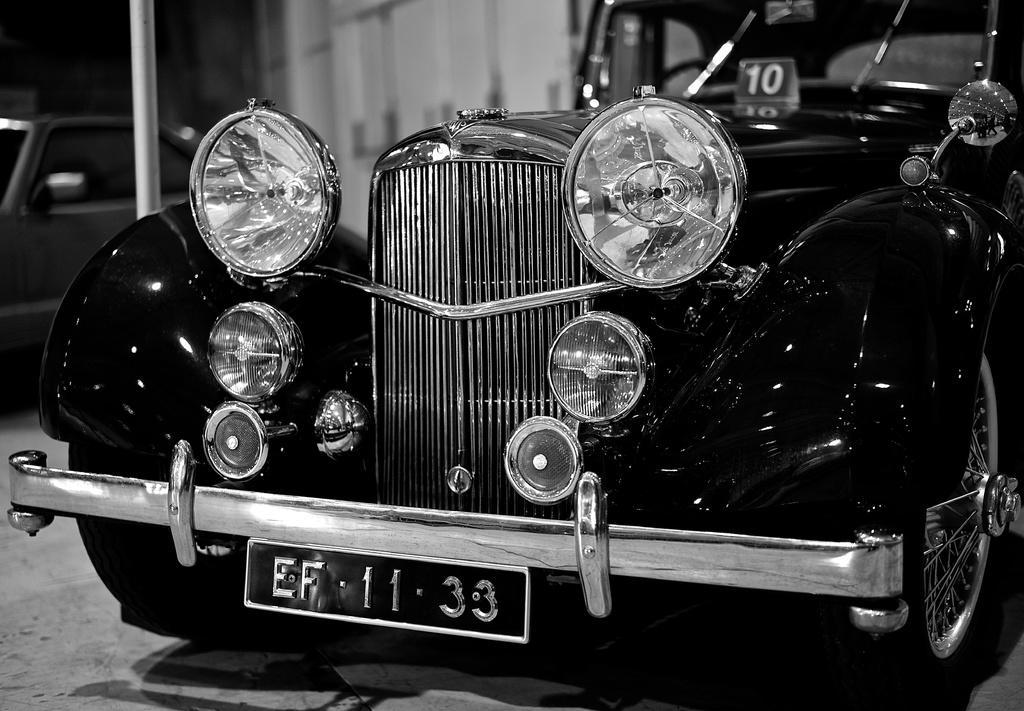Please provide a concise description of this image. It is a black and white image and there is a car in the foreground. 